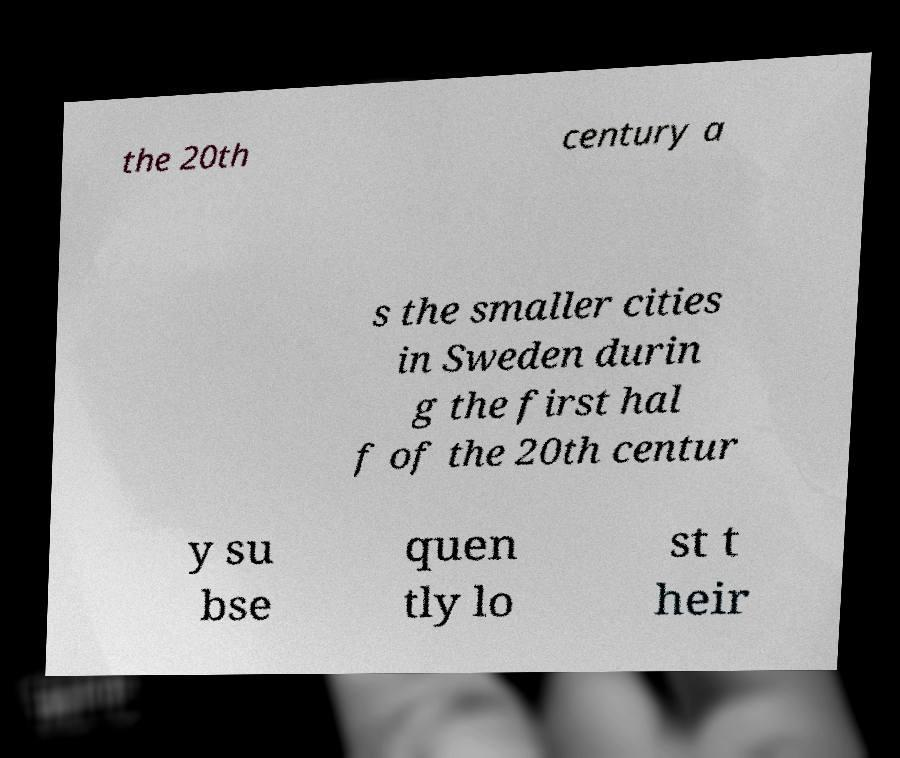There's text embedded in this image that I need extracted. Can you transcribe it verbatim? the 20th century a s the smaller cities in Sweden durin g the first hal f of the 20th centur y su bse quen tly lo st t heir 